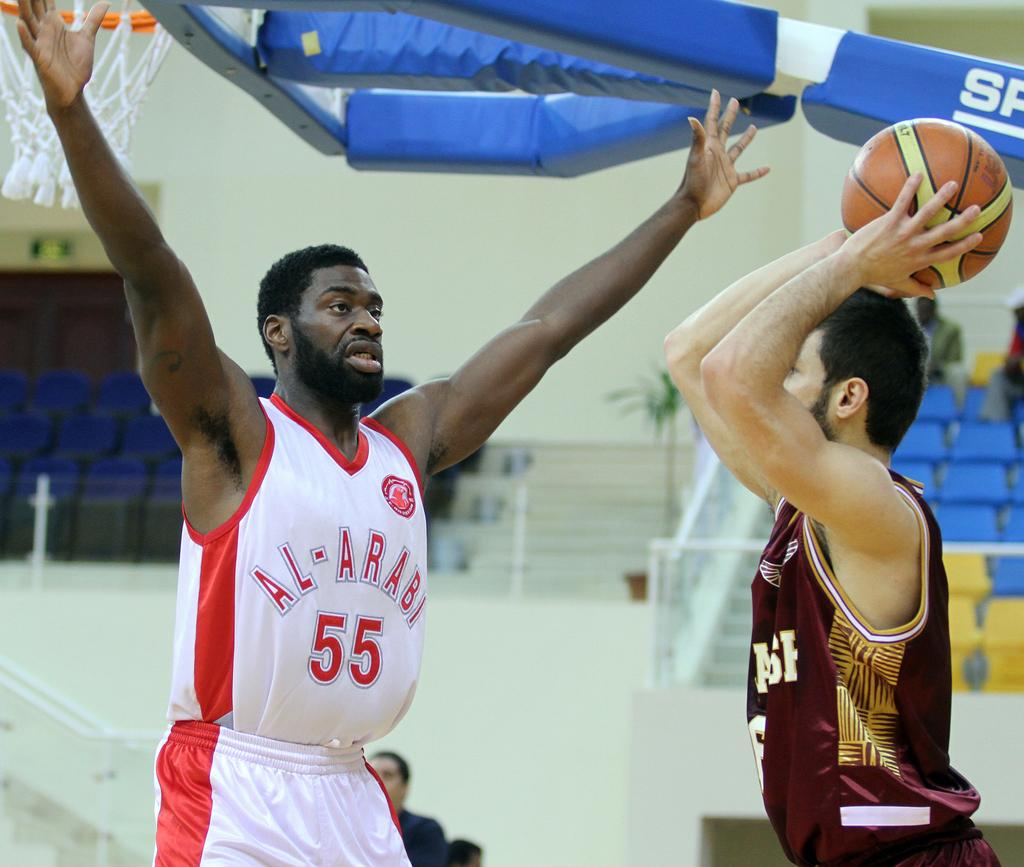Provide a one-sentence caption for the provided image. Basketball player that plays for Al-Arabi guarding someone. 